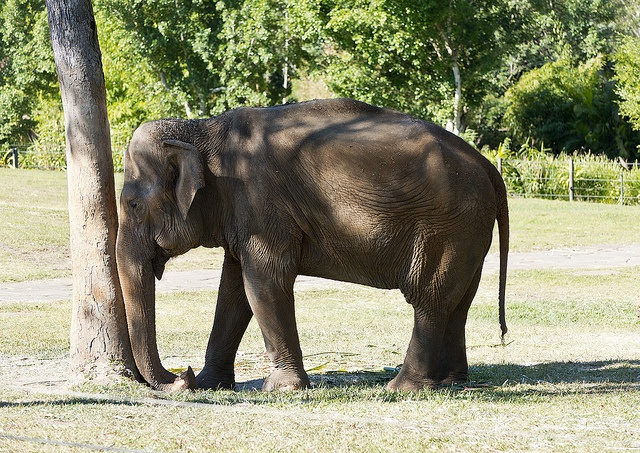Describe the objects in this image and their specific colors. I can see a elephant in darkgreen, black, and gray tones in this image. 